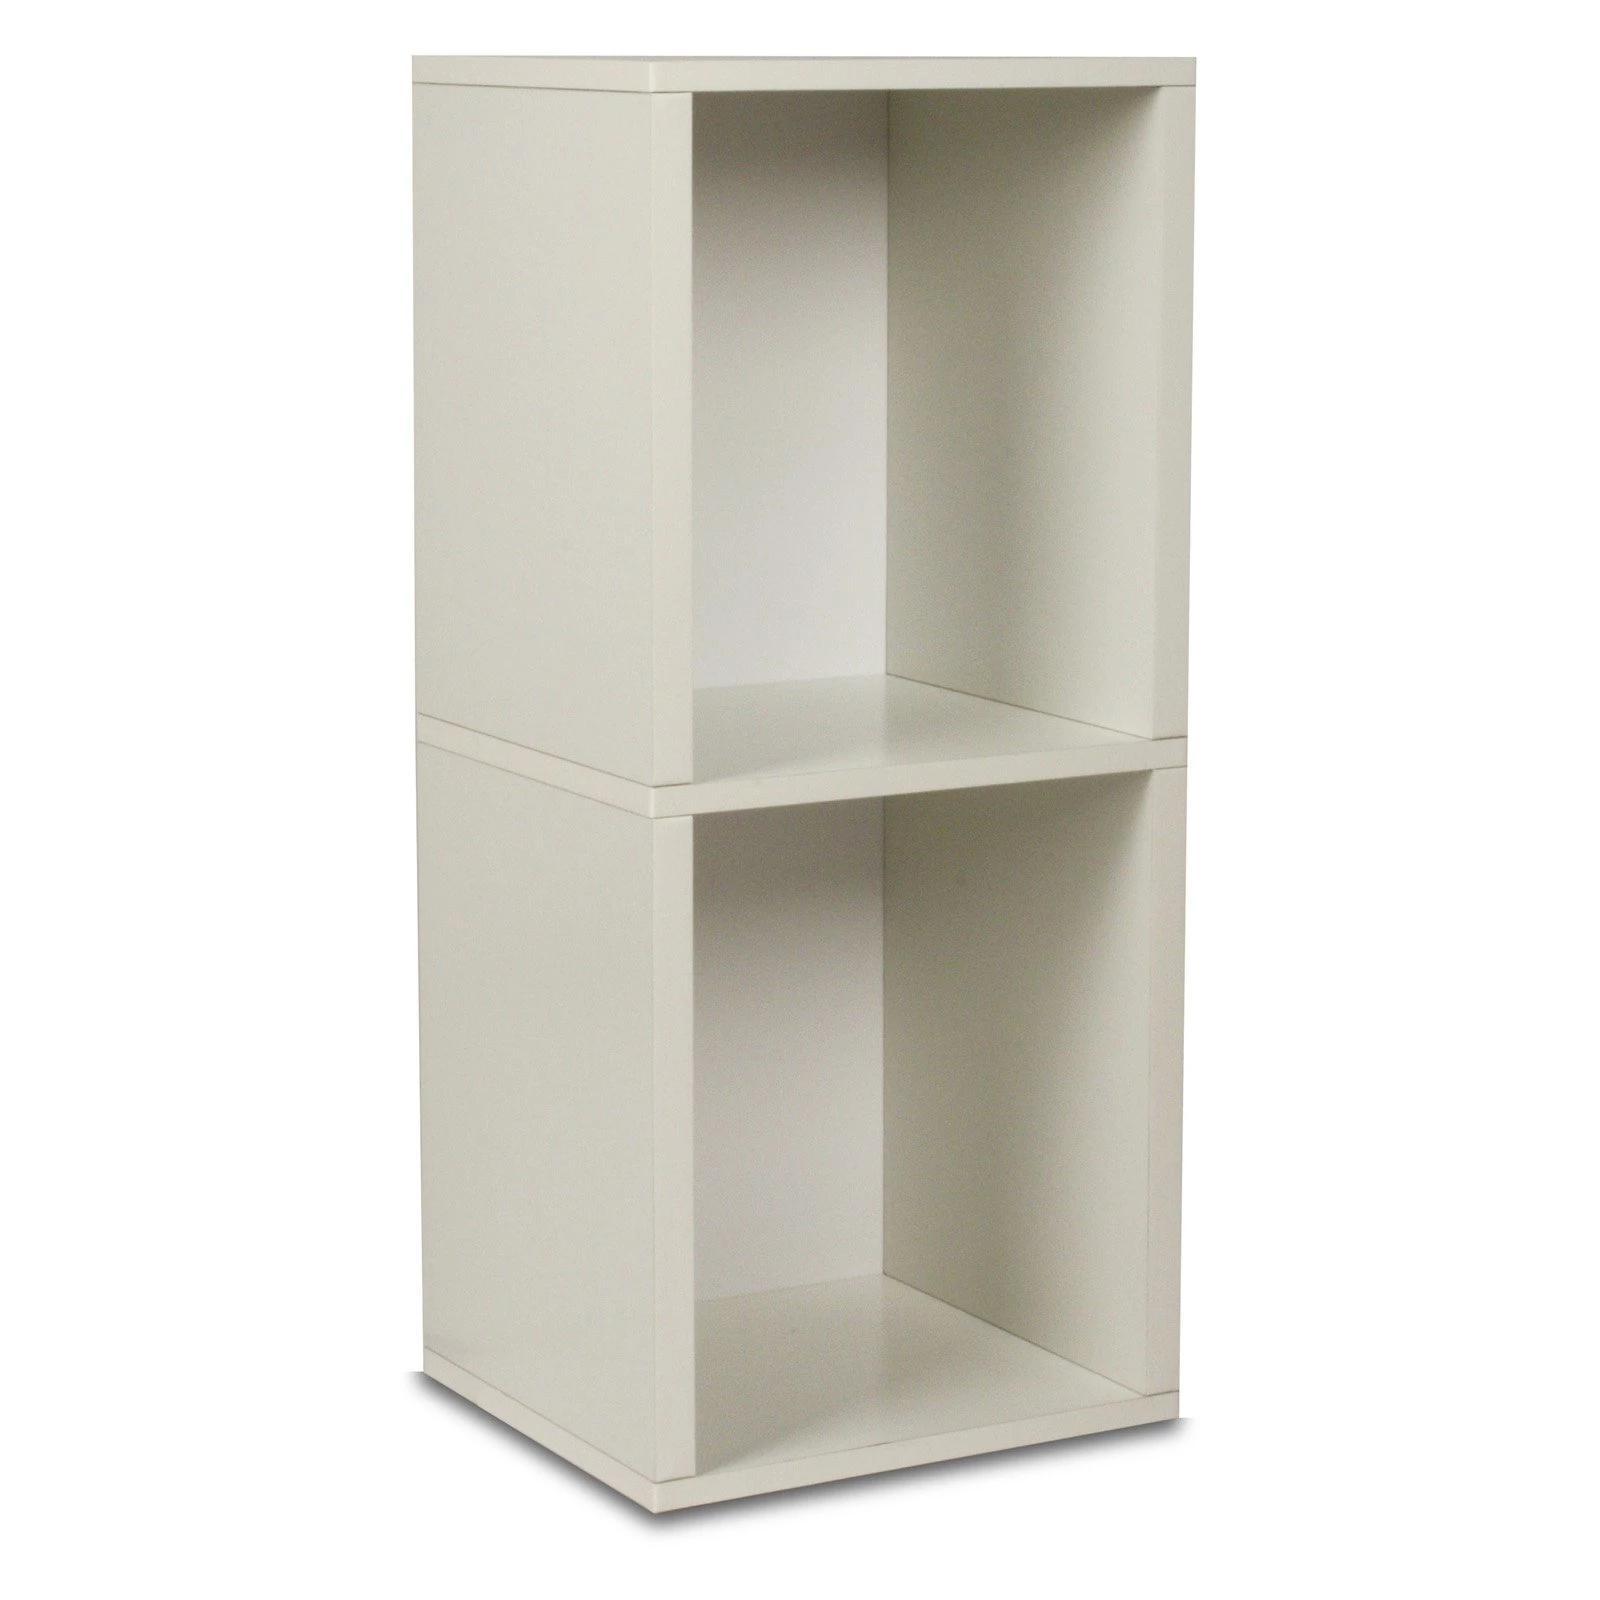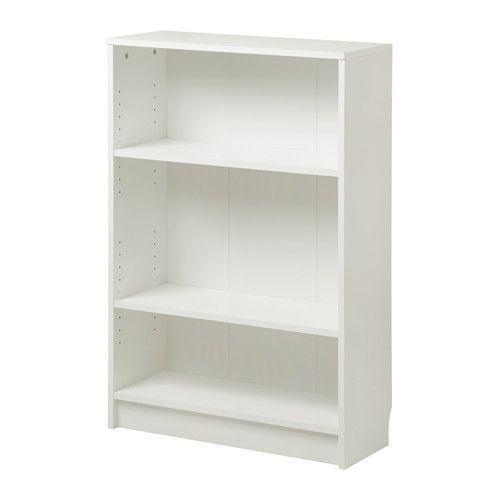The first image is the image on the left, the second image is the image on the right. Evaluate the accuracy of this statement regarding the images: "In the left image, there's a bookcase with a single shelf angled toward the right.". Is it true? Answer yes or no. Yes. The first image is the image on the left, the second image is the image on the right. Examine the images to the left and right. Is the description "Two boxy white bookcases are different sizes, one of them with exactly three shelves and the other with two." accurate? Answer yes or no. Yes. 